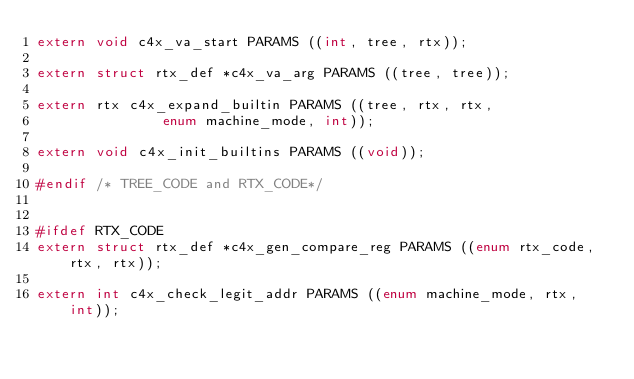Convert code to text. <code><loc_0><loc_0><loc_500><loc_500><_C_>extern void c4x_va_start PARAMS ((int, tree, rtx));

extern struct rtx_def *c4x_va_arg PARAMS ((tree, tree));

extern rtx c4x_expand_builtin PARAMS ((tree, rtx, rtx,
				       enum machine_mode, int));

extern void c4x_init_builtins PARAMS ((void));

#endif /* TREE_CODE and RTX_CODE*/


#ifdef RTX_CODE
extern struct rtx_def *c4x_gen_compare_reg PARAMS ((enum rtx_code, rtx, rtx));

extern int c4x_check_legit_addr PARAMS ((enum machine_mode, rtx, int));
</code> 